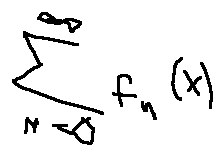Convert formula to latex. <formula><loc_0><loc_0><loc_500><loc_500>\sum \lim i t s _ { n = 0 } ^ { \infty } f _ { n } ( x )</formula> 